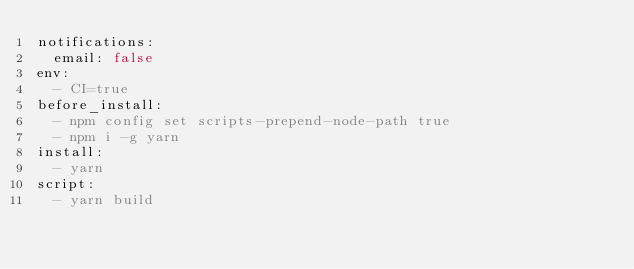<code> <loc_0><loc_0><loc_500><loc_500><_YAML_>notifications:
  email: false
env:
  - CI=true
before_install:
  - npm config set scripts-prepend-node-path true
  - npm i -g yarn
install:
  - yarn
script:
  - yarn build
</code> 